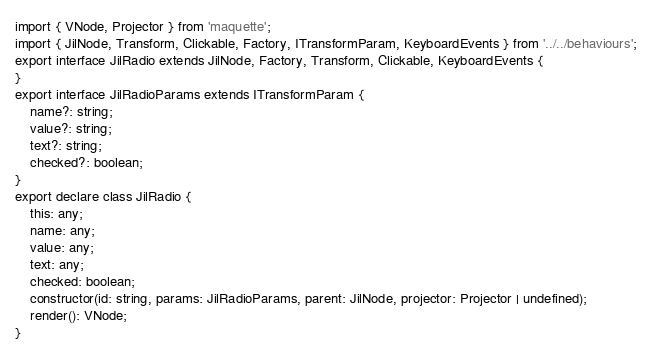Convert code to text. <code><loc_0><loc_0><loc_500><loc_500><_TypeScript_>import { VNode, Projector } from 'maquette';
import { JilNode, Transform, Clickable, Factory, ITransformParam, KeyboardEvents } from '../../behaviours';
export interface JilRadio extends JilNode, Factory, Transform, Clickable, KeyboardEvents {
}
export interface JilRadioParams extends ITransformParam {
    name?: string;
    value?: string;
    text?: string;
    checked?: boolean;
}
export declare class JilRadio {
    this: any;
    name: any;
    value: any;
    text: any;
    checked: boolean;
    constructor(id: string, params: JilRadioParams, parent: JilNode, projector: Projector | undefined);
    render(): VNode;
}
</code> 